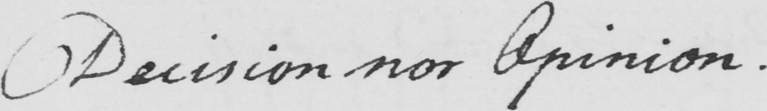What text is written in this handwritten line? Decision nor Opinion . 